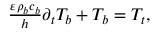Convert formula to latex. <formula><loc_0><loc_0><loc_500><loc_500>\begin{array} { r } { \frac { \varepsilon \rho _ { b } c _ { b } } { h } \partial _ { t } T _ { b } + T _ { b } = T _ { t } , } \end{array}</formula> 